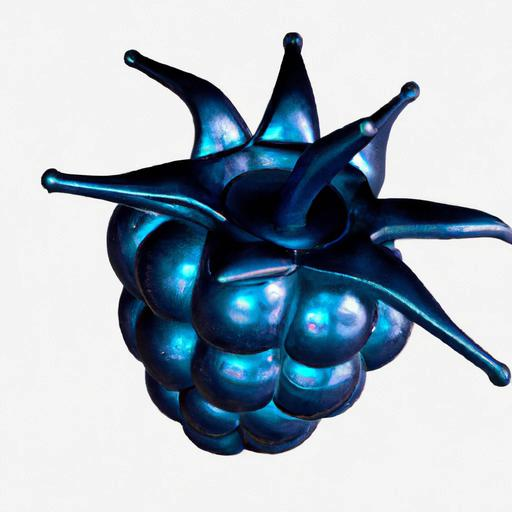Can you guess the material the object is made of? Based on the image, the object appears to be made of a glossy material that could be metal or ceramic, given its reflective surface and the way it plays with light, akin to glazed pottery or polished metal. 